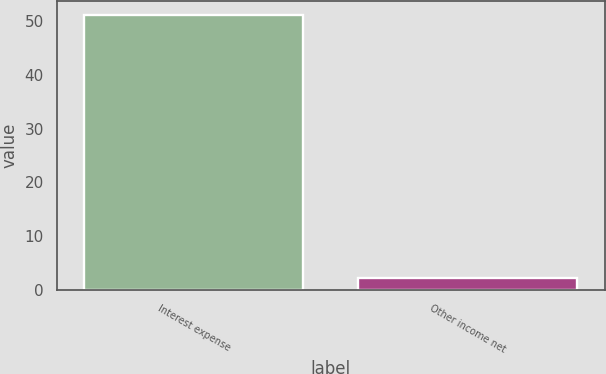Convert chart to OTSL. <chart><loc_0><loc_0><loc_500><loc_500><bar_chart><fcel>Interest expense<fcel>Other income net<nl><fcel>51.2<fcel>2.3<nl></chart> 